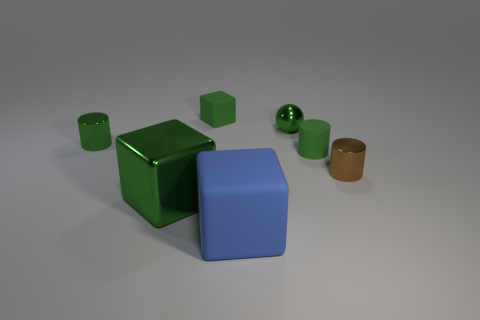Is the number of brown things less than the number of large spheres?
Provide a short and direct response. No. Does the matte cylinder have the same size as the metallic cylinder that is to the left of the small brown metal object?
Give a very brief answer. Yes. How many metallic objects are either big gray spheres or blue blocks?
Keep it short and to the point. 0. Is the number of cylinders greater than the number of tiny blue shiny blocks?
Offer a very short reply. Yes. The metallic cube that is the same color as the metallic sphere is what size?
Your response must be concise. Large. There is a small green shiny thing that is right of the block on the right side of the small green rubber block; what is its shape?
Your answer should be very brief. Sphere. Are there any tiny green rubber things that are right of the green sphere that is on the left side of the small brown shiny cylinder that is on the right side of the matte cylinder?
Your answer should be very brief. Yes. There is a metallic cube that is the same size as the blue rubber thing; what is its color?
Your response must be concise. Green. What is the shape of the thing that is both in front of the tiny brown metallic cylinder and to the right of the large metallic block?
Provide a succinct answer. Cube. How big is the thing that is in front of the large green block in front of the green matte cylinder?
Your response must be concise. Large. 